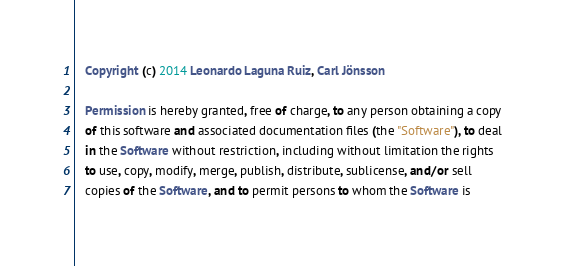<code> <loc_0><loc_0><loc_500><loc_500><_OCaml_>
   Copyright (c) 2014 Leonardo Laguna Ruiz, Carl Jönsson

   Permission is hereby granted, free of charge, to any person obtaining a copy
   of this software and associated documentation files (the "Software"), to deal
   in the Software without restriction, including without limitation the rights
   to use, copy, modify, merge, publish, distribute, sublicense, and/or sell
   copies of the Software, and to permit persons to whom the Software is</code> 